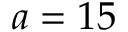Convert formula to latex. <formula><loc_0><loc_0><loc_500><loc_500>a = 1 5</formula> 